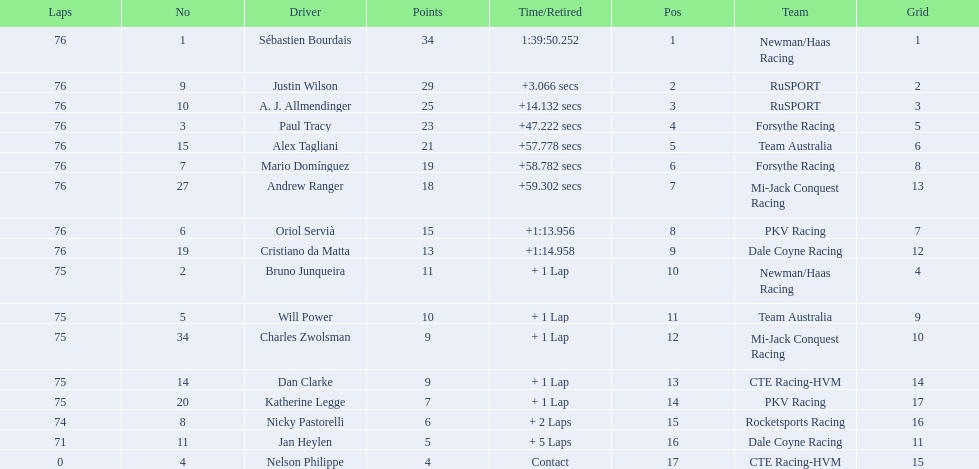What was the total points that canada earned together? 62. 